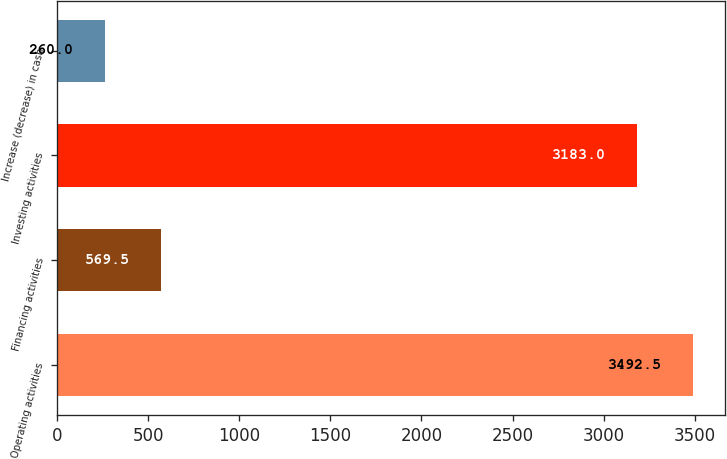<chart> <loc_0><loc_0><loc_500><loc_500><bar_chart><fcel>Operating activities<fcel>Financing activities<fcel>Investing activities<fcel>Increase (decrease) in cash<nl><fcel>3492.5<fcel>569.5<fcel>3183<fcel>260<nl></chart> 